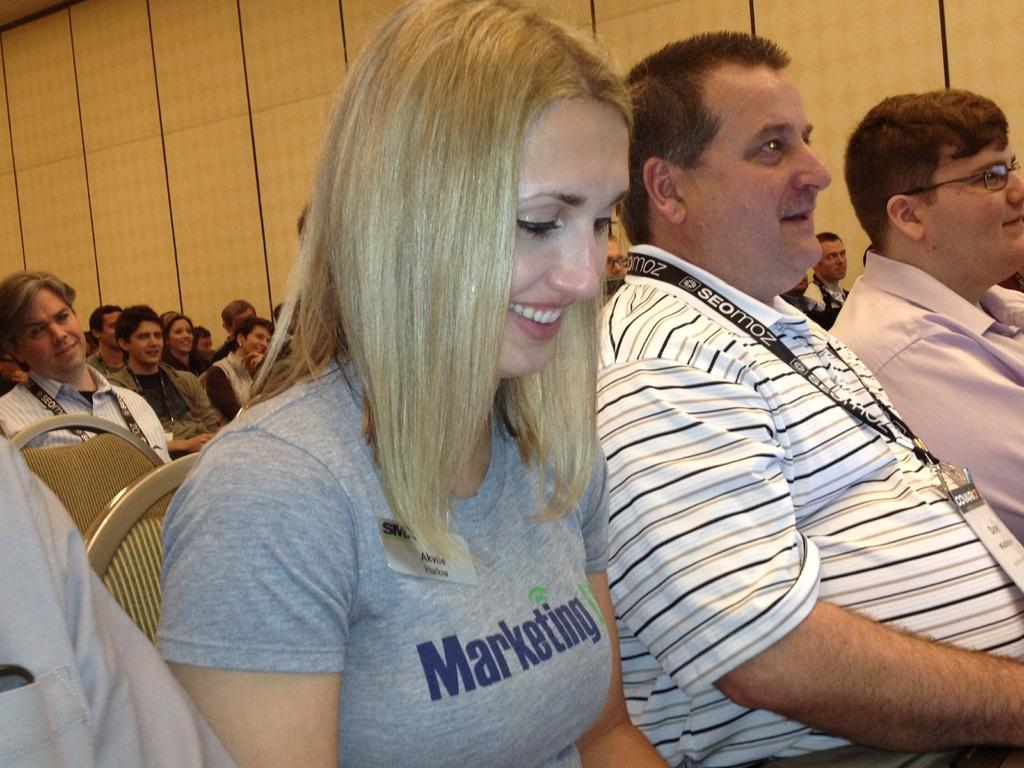What is happening in the image? There is a group of people in the image, and they are sitting on chairs. Can you describe the person in front? The person in front is wearing a gray color dress. What can be seen in the background of the image? The background of the image includes a wall in brown color. How many cherries are on the channel in the image? There are no cherries or channels present in the image. 